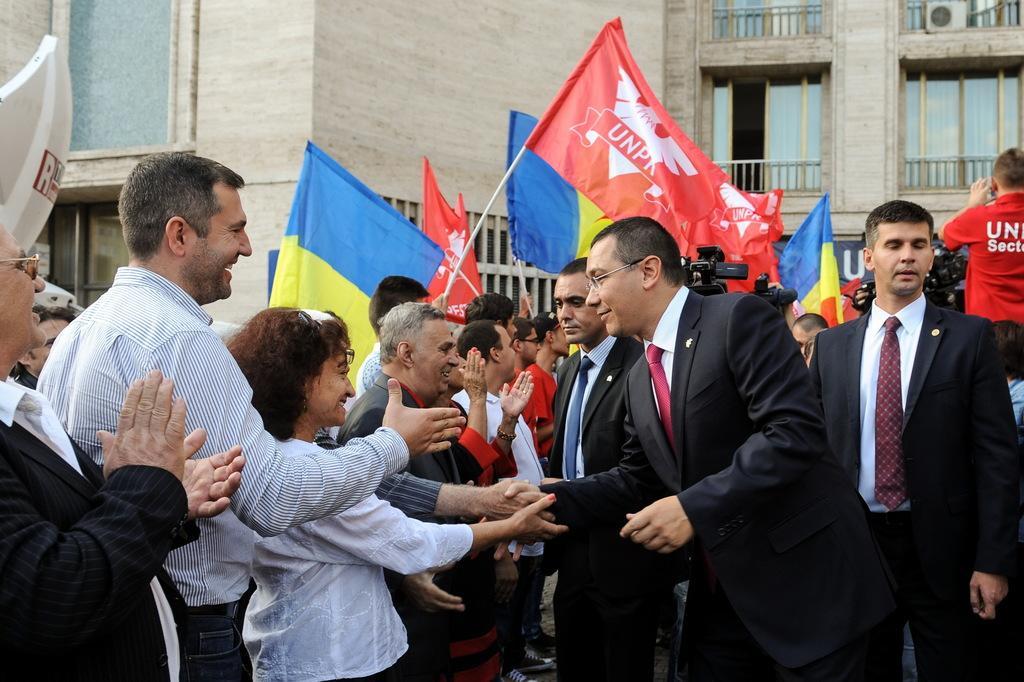In one or two sentences, can you explain what this image depicts? In this image there is a person wearing a blazer and tie. He is shaking his hand with the person. Few people are on the road. Few people are holding the flags. Right side few people are holding the cameras. Background there is a building having balconies. 